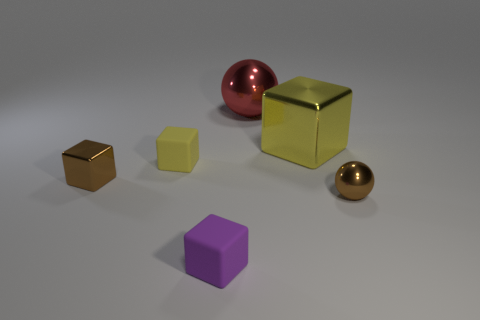Is the shape of the large red shiny object the same as the small purple object?
Your answer should be very brief. No. What number of shiny objects are large gray balls or large objects?
Your answer should be compact. 2. What material is the tiny thing that is the same color as the big metallic cube?
Provide a succinct answer. Rubber. Do the red thing and the brown ball have the same size?
Offer a terse response. No. What number of things are either tiny brown shiny cubes or small things behind the purple cube?
Provide a short and direct response. 3. There is a yellow block that is the same size as the brown cube; what is it made of?
Give a very brief answer. Rubber. The tiny block that is both right of the brown metallic block and behind the purple matte cube is made of what material?
Ensure brevity in your answer.  Rubber. There is a metallic sphere left of the big yellow shiny thing; is there a yellow rubber thing that is behind it?
Ensure brevity in your answer.  No. There is a object that is both right of the large red thing and in front of the tiny brown cube; what size is it?
Offer a terse response. Small. How many gray objects are either tiny things or small blocks?
Your answer should be very brief. 0. 